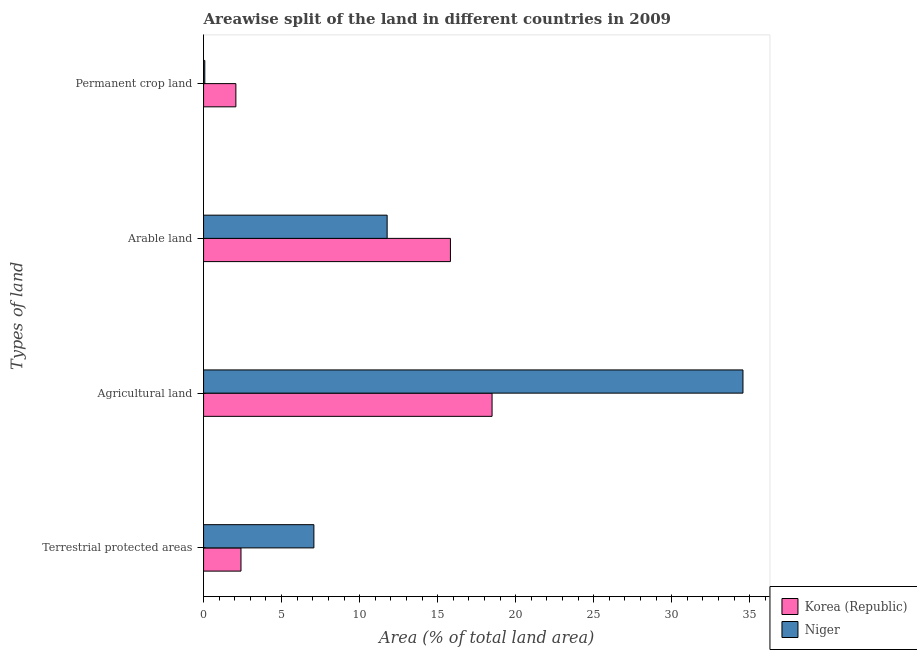How many different coloured bars are there?
Your response must be concise. 2. Are the number of bars per tick equal to the number of legend labels?
Your response must be concise. Yes. How many bars are there on the 1st tick from the bottom?
Your response must be concise. 2. What is the label of the 3rd group of bars from the top?
Your answer should be very brief. Agricultural land. What is the percentage of area under permanent crop land in Niger?
Ensure brevity in your answer.  0.08. Across all countries, what is the maximum percentage of land under terrestrial protection?
Your answer should be compact. 7.07. Across all countries, what is the minimum percentage of area under permanent crop land?
Give a very brief answer. 0.08. In which country was the percentage of area under agricultural land maximum?
Ensure brevity in your answer.  Niger. In which country was the percentage of area under arable land minimum?
Provide a short and direct response. Niger. What is the total percentage of area under arable land in the graph?
Offer a terse response. 27.58. What is the difference between the percentage of area under agricultural land in Niger and that in Korea (Republic)?
Provide a succinct answer. 16.08. What is the difference between the percentage of area under arable land in Niger and the percentage of area under permanent crop land in Korea (Republic)?
Provide a short and direct response. 9.69. What is the average percentage of land under terrestrial protection per country?
Provide a succinct answer. 4.73. What is the difference between the percentage of land under terrestrial protection and percentage of area under agricultural land in Niger?
Provide a succinct answer. -27.49. In how many countries, is the percentage of area under permanent crop land greater than 5 %?
Provide a short and direct response. 0. What is the ratio of the percentage of area under permanent crop land in Korea (Republic) to that in Niger?
Offer a terse response. 26.22. What is the difference between the highest and the second highest percentage of land under terrestrial protection?
Offer a terse response. 4.67. What is the difference between the highest and the lowest percentage of area under agricultural land?
Provide a succinct answer. 16.08. Is the sum of the percentage of area under permanent crop land in Niger and Korea (Republic) greater than the maximum percentage of land under terrestrial protection across all countries?
Your answer should be very brief. No. Is it the case that in every country, the sum of the percentage of land under terrestrial protection and percentage of area under agricultural land is greater than the sum of percentage of area under permanent crop land and percentage of area under arable land?
Give a very brief answer. No. What does the 2nd bar from the top in Terrestrial protected areas represents?
Your answer should be very brief. Korea (Republic). What does the 1st bar from the bottom in Arable land represents?
Ensure brevity in your answer.  Korea (Republic). How many bars are there?
Your response must be concise. 8. How many countries are there in the graph?
Ensure brevity in your answer.  2. What is the difference between two consecutive major ticks on the X-axis?
Provide a short and direct response. 5. Are the values on the major ticks of X-axis written in scientific E-notation?
Provide a short and direct response. No. Does the graph contain any zero values?
Your answer should be compact. No. How are the legend labels stacked?
Offer a very short reply. Vertical. What is the title of the graph?
Ensure brevity in your answer.  Areawise split of the land in different countries in 2009. What is the label or title of the X-axis?
Make the answer very short. Area (% of total land area). What is the label or title of the Y-axis?
Keep it short and to the point. Types of land. What is the Area (% of total land area) in Korea (Republic) in Terrestrial protected areas?
Offer a terse response. 2.4. What is the Area (% of total land area) of Niger in Terrestrial protected areas?
Provide a succinct answer. 7.07. What is the Area (% of total land area) in Korea (Republic) in Agricultural land?
Offer a terse response. 18.49. What is the Area (% of total land area) of Niger in Agricultural land?
Your answer should be compact. 34.56. What is the Area (% of total land area) in Korea (Republic) in Arable land?
Your answer should be very brief. 15.82. What is the Area (% of total land area) of Niger in Arable land?
Give a very brief answer. 11.76. What is the Area (% of total land area) of Korea (Republic) in Permanent crop land?
Your answer should be compact. 2.07. What is the Area (% of total land area) of Niger in Permanent crop land?
Give a very brief answer. 0.08. Across all Types of land, what is the maximum Area (% of total land area) of Korea (Republic)?
Your response must be concise. 18.49. Across all Types of land, what is the maximum Area (% of total land area) of Niger?
Ensure brevity in your answer.  34.56. Across all Types of land, what is the minimum Area (% of total land area) in Korea (Republic)?
Provide a succinct answer. 2.07. Across all Types of land, what is the minimum Area (% of total land area) of Niger?
Offer a terse response. 0.08. What is the total Area (% of total land area) in Korea (Republic) in the graph?
Your response must be concise. 38.77. What is the total Area (% of total land area) in Niger in the graph?
Your answer should be compact. 53.47. What is the difference between the Area (% of total land area) of Korea (Republic) in Terrestrial protected areas and that in Agricultural land?
Provide a short and direct response. -16.09. What is the difference between the Area (% of total land area) in Niger in Terrestrial protected areas and that in Agricultural land?
Offer a terse response. -27.49. What is the difference between the Area (% of total land area) in Korea (Republic) in Terrestrial protected areas and that in Arable land?
Your answer should be compact. -13.42. What is the difference between the Area (% of total land area) in Niger in Terrestrial protected areas and that in Arable land?
Your answer should be compact. -4.69. What is the difference between the Area (% of total land area) in Korea (Republic) in Terrestrial protected areas and that in Permanent crop land?
Ensure brevity in your answer.  0.33. What is the difference between the Area (% of total land area) in Niger in Terrestrial protected areas and that in Permanent crop land?
Your answer should be very brief. 6.99. What is the difference between the Area (% of total land area) of Korea (Republic) in Agricultural land and that in Arable land?
Give a very brief answer. 2.67. What is the difference between the Area (% of total land area) in Niger in Agricultural land and that in Arable land?
Provide a succinct answer. 22.8. What is the difference between the Area (% of total land area) of Korea (Republic) in Agricultural land and that in Permanent crop land?
Offer a very short reply. 16.42. What is the difference between the Area (% of total land area) in Niger in Agricultural land and that in Permanent crop land?
Your answer should be very brief. 34.48. What is the difference between the Area (% of total land area) in Korea (Republic) in Arable land and that in Permanent crop land?
Your answer should be very brief. 13.75. What is the difference between the Area (% of total land area) of Niger in Arable land and that in Permanent crop land?
Provide a succinct answer. 11.68. What is the difference between the Area (% of total land area) in Korea (Republic) in Terrestrial protected areas and the Area (% of total land area) in Niger in Agricultural land?
Your answer should be compact. -32.17. What is the difference between the Area (% of total land area) of Korea (Republic) in Terrestrial protected areas and the Area (% of total land area) of Niger in Arable land?
Offer a terse response. -9.37. What is the difference between the Area (% of total land area) in Korea (Republic) in Terrestrial protected areas and the Area (% of total land area) in Niger in Permanent crop land?
Offer a terse response. 2.32. What is the difference between the Area (% of total land area) in Korea (Republic) in Agricultural land and the Area (% of total land area) in Niger in Arable land?
Give a very brief answer. 6.72. What is the difference between the Area (% of total land area) in Korea (Republic) in Agricultural land and the Area (% of total land area) in Niger in Permanent crop land?
Offer a very short reply. 18.41. What is the difference between the Area (% of total land area) of Korea (Republic) in Arable land and the Area (% of total land area) of Niger in Permanent crop land?
Your response must be concise. 15.74. What is the average Area (% of total land area) of Korea (Republic) per Types of land?
Your response must be concise. 9.69. What is the average Area (% of total land area) in Niger per Types of land?
Offer a very short reply. 13.37. What is the difference between the Area (% of total land area) in Korea (Republic) and Area (% of total land area) in Niger in Terrestrial protected areas?
Your answer should be very brief. -4.67. What is the difference between the Area (% of total land area) of Korea (Republic) and Area (% of total land area) of Niger in Agricultural land?
Provide a succinct answer. -16.08. What is the difference between the Area (% of total land area) in Korea (Republic) and Area (% of total land area) in Niger in Arable land?
Offer a very short reply. 4.06. What is the difference between the Area (% of total land area) in Korea (Republic) and Area (% of total land area) in Niger in Permanent crop land?
Keep it short and to the point. 1.99. What is the ratio of the Area (% of total land area) in Korea (Republic) in Terrestrial protected areas to that in Agricultural land?
Offer a terse response. 0.13. What is the ratio of the Area (% of total land area) in Niger in Terrestrial protected areas to that in Agricultural land?
Offer a very short reply. 0.2. What is the ratio of the Area (% of total land area) of Korea (Republic) in Terrestrial protected areas to that in Arable land?
Ensure brevity in your answer.  0.15. What is the ratio of the Area (% of total land area) in Niger in Terrestrial protected areas to that in Arable land?
Your answer should be very brief. 0.6. What is the ratio of the Area (% of total land area) of Korea (Republic) in Terrestrial protected areas to that in Permanent crop land?
Provide a short and direct response. 1.16. What is the ratio of the Area (% of total land area) in Niger in Terrestrial protected areas to that in Permanent crop land?
Keep it short and to the point. 89.55. What is the ratio of the Area (% of total land area) in Korea (Republic) in Agricultural land to that in Arable land?
Provide a succinct answer. 1.17. What is the ratio of the Area (% of total land area) in Niger in Agricultural land to that in Arable land?
Keep it short and to the point. 2.94. What is the ratio of the Area (% of total land area) of Korea (Republic) in Agricultural land to that in Permanent crop land?
Offer a very short reply. 8.93. What is the ratio of the Area (% of total land area) of Niger in Agricultural land to that in Permanent crop land?
Ensure brevity in your answer.  437.82. What is the ratio of the Area (% of total land area) in Korea (Republic) in Arable land to that in Permanent crop land?
Provide a short and direct response. 7.64. What is the ratio of the Area (% of total land area) in Niger in Arable land to that in Permanent crop land?
Make the answer very short. 149. What is the difference between the highest and the second highest Area (% of total land area) of Korea (Republic)?
Give a very brief answer. 2.67. What is the difference between the highest and the second highest Area (% of total land area) of Niger?
Your answer should be compact. 22.8. What is the difference between the highest and the lowest Area (% of total land area) of Korea (Republic)?
Ensure brevity in your answer.  16.42. What is the difference between the highest and the lowest Area (% of total land area) in Niger?
Your answer should be compact. 34.48. 